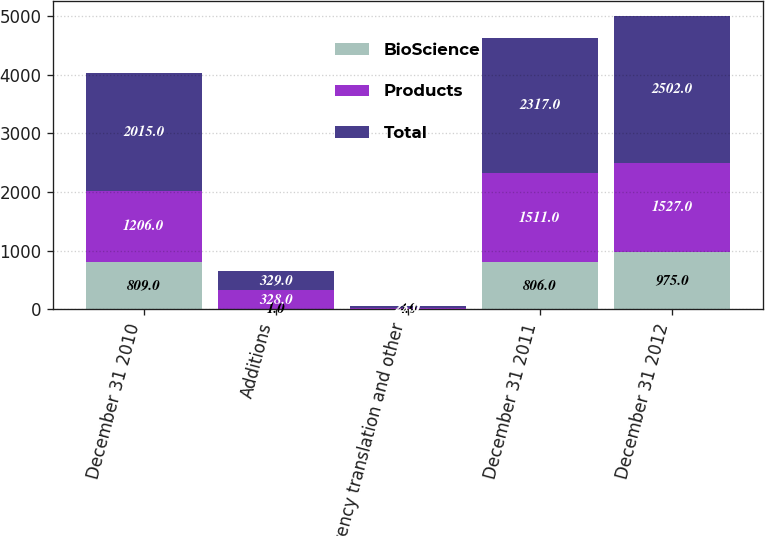<chart> <loc_0><loc_0><loc_500><loc_500><stacked_bar_chart><ecel><fcel>December 31 2010<fcel>Additions<fcel>Currency translation and other<fcel>December 31 2011<fcel>December 31 2012<nl><fcel>BioScience<fcel>809<fcel>1<fcel>4<fcel>806<fcel>975<nl><fcel>Products<fcel>1206<fcel>328<fcel>23<fcel>1511<fcel>1527<nl><fcel>Total<fcel>2015<fcel>329<fcel>27<fcel>2317<fcel>2502<nl></chart> 